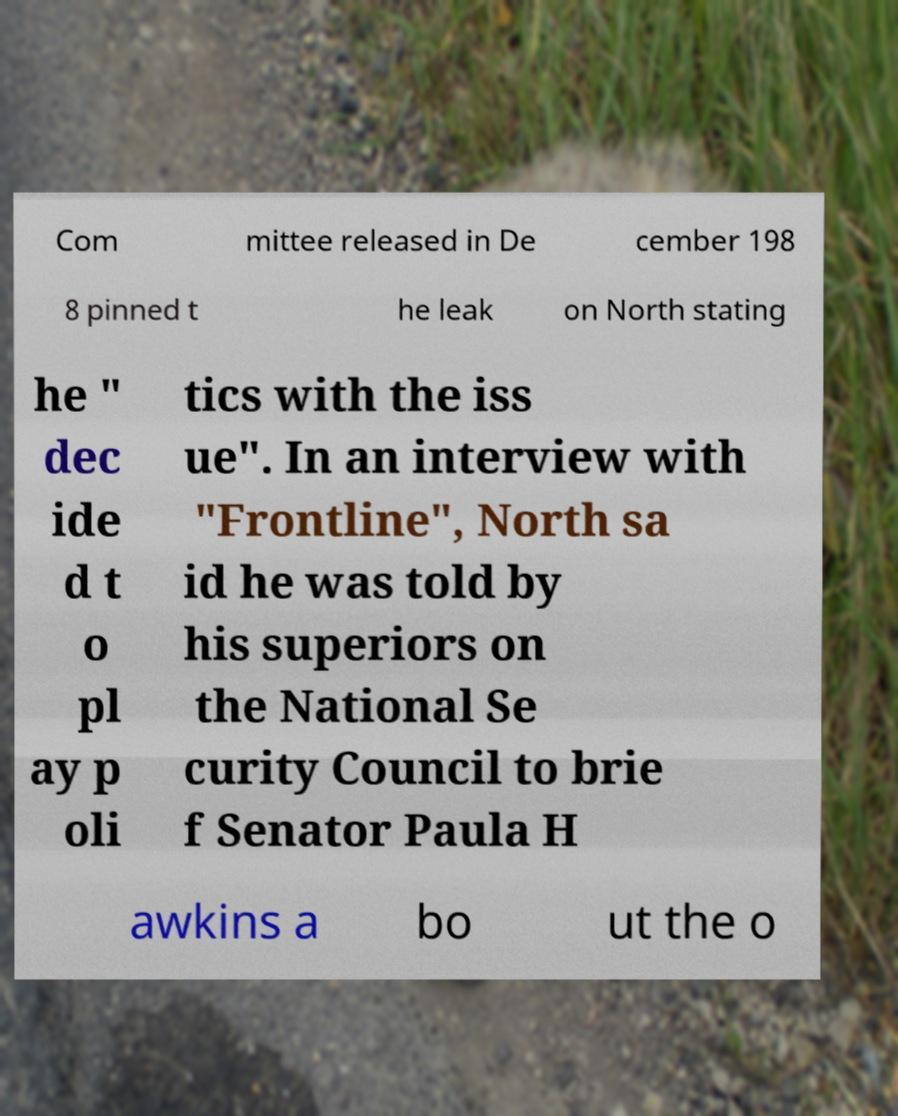There's text embedded in this image that I need extracted. Can you transcribe it verbatim? Com mittee released in De cember 198 8 pinned t he leak on North stating he " dec ide d t o pl ay p oli tics with the iss ue". In an interview with "Frontline", North sa id he was told by his superiors on the National Se curity Council to brie f Senator Paula H awkins a bo ut the o 